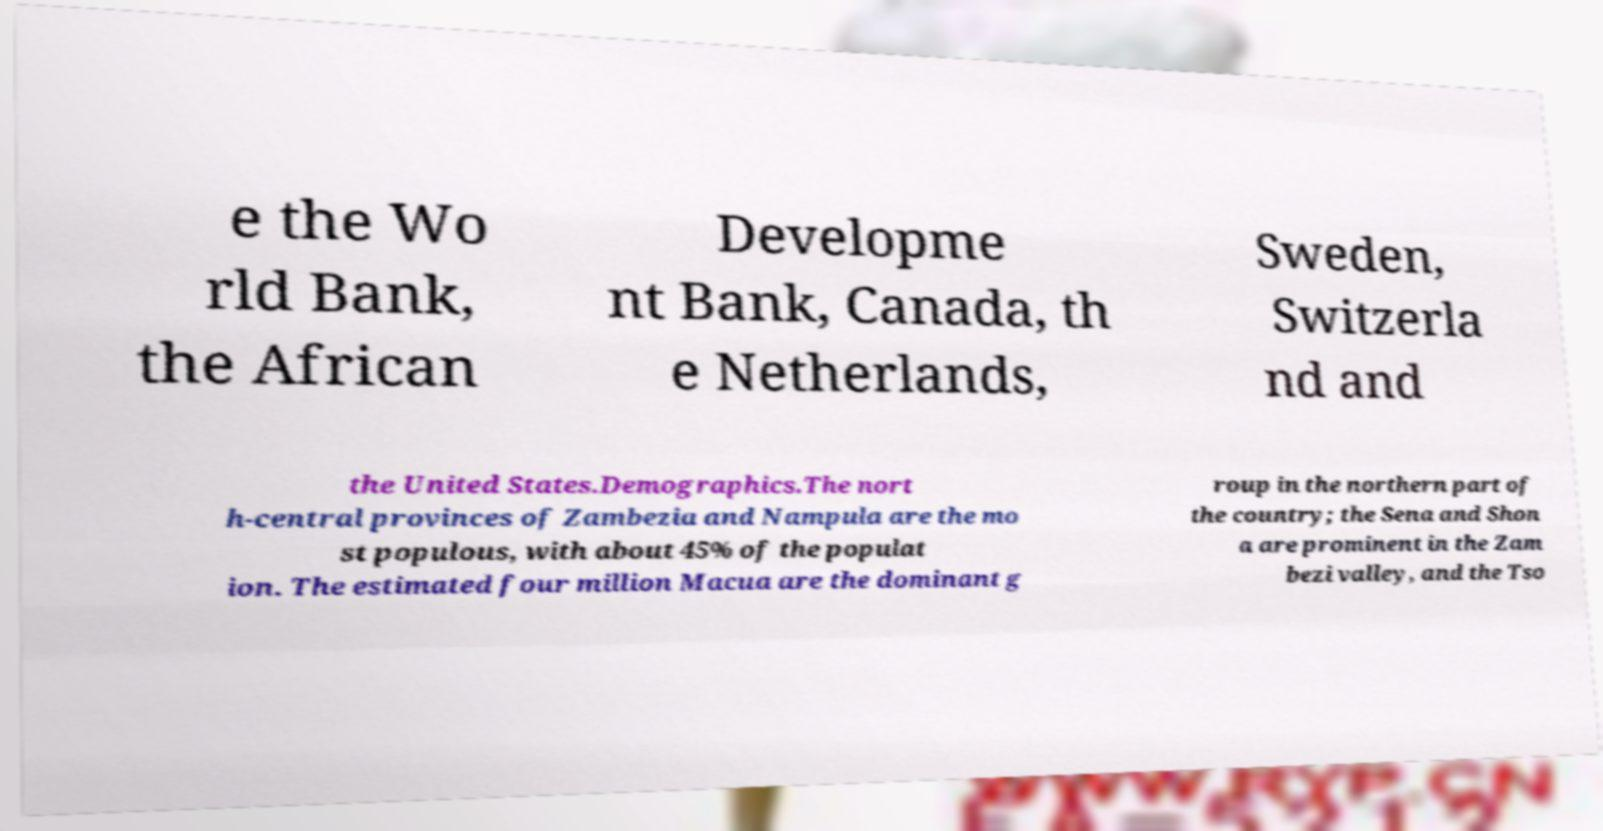Please read and relay the text visible in this image. What does it say? e the Wo rld Bank, the African Developme nt Bank, Canada, th e Netherlands, Sweden, Switzerla nd and the United States.Demographics.The nort h-central provinces of Zambezia and Nampula are the mo st populous, with about 45% of the populat ion. The estimated four million Macua are the dominant g roup in the northern part of the country; the Sena and Shon a are prominent in the Zam bezi valley, and the Tso 